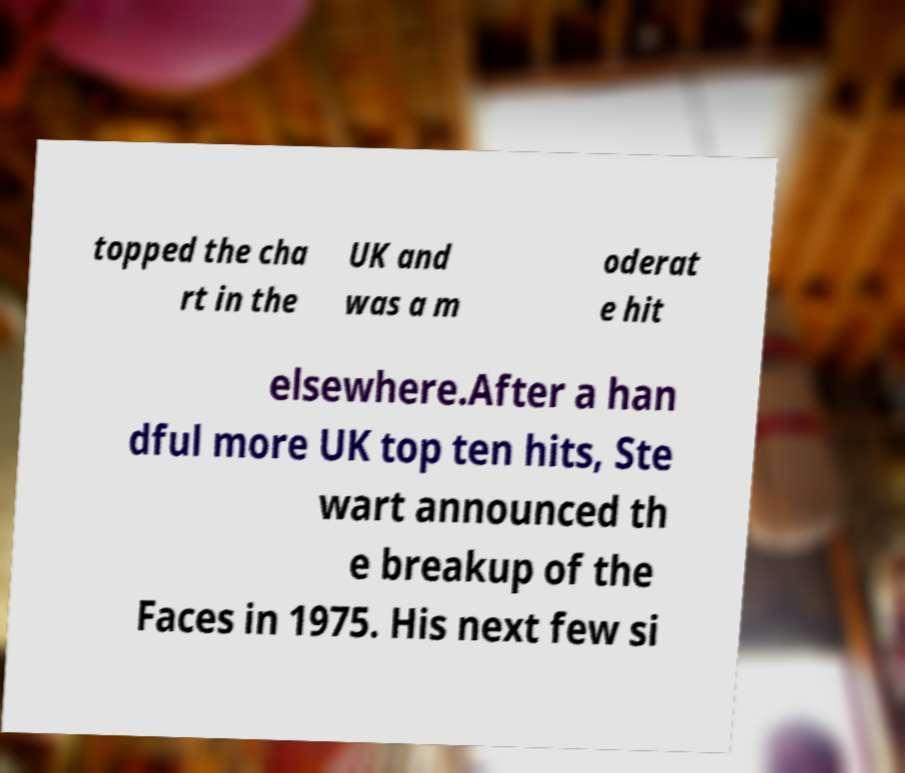I need the written content from this picture converted into text. Can you do that? topped the cha rt in the UK and was a m oderat e hit elsewhere.After a han dful more UK top ten hits, Ste wart announced th e breakup of the Faces in 1975. His next few si 